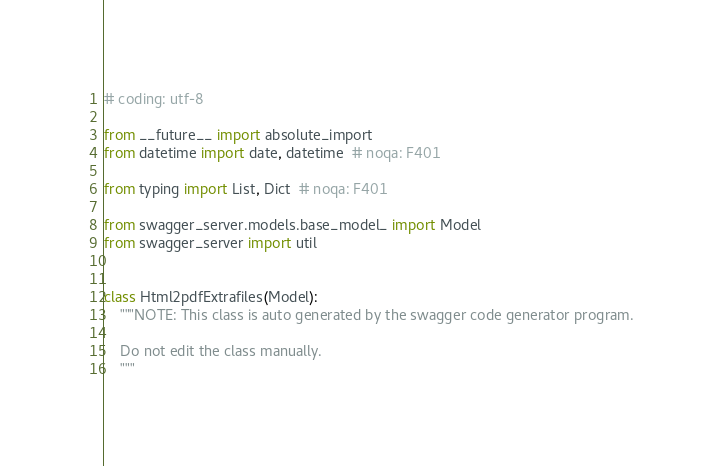<code> <loc_0><loc_0><loc_500><loc_500><_Python_># coding: utf-8

from __future__ import absolute_import
from datetime import date, datetime  # noqa: F401

from typing import List, Dict  # noqa: F401

from swagger_server.models.base_model_ import Model
from swagger_server import util


class Html2pdfExtrafiles(Model):
    """NOTE: This class is auto generated by the swagger code generator program.

    Do not edit the class manually.
    """</code> 